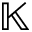Convert formula to latex. <formula><loc_0><loc_0><loc_500><loc_500>{ \mathbb { K } }</formula> 